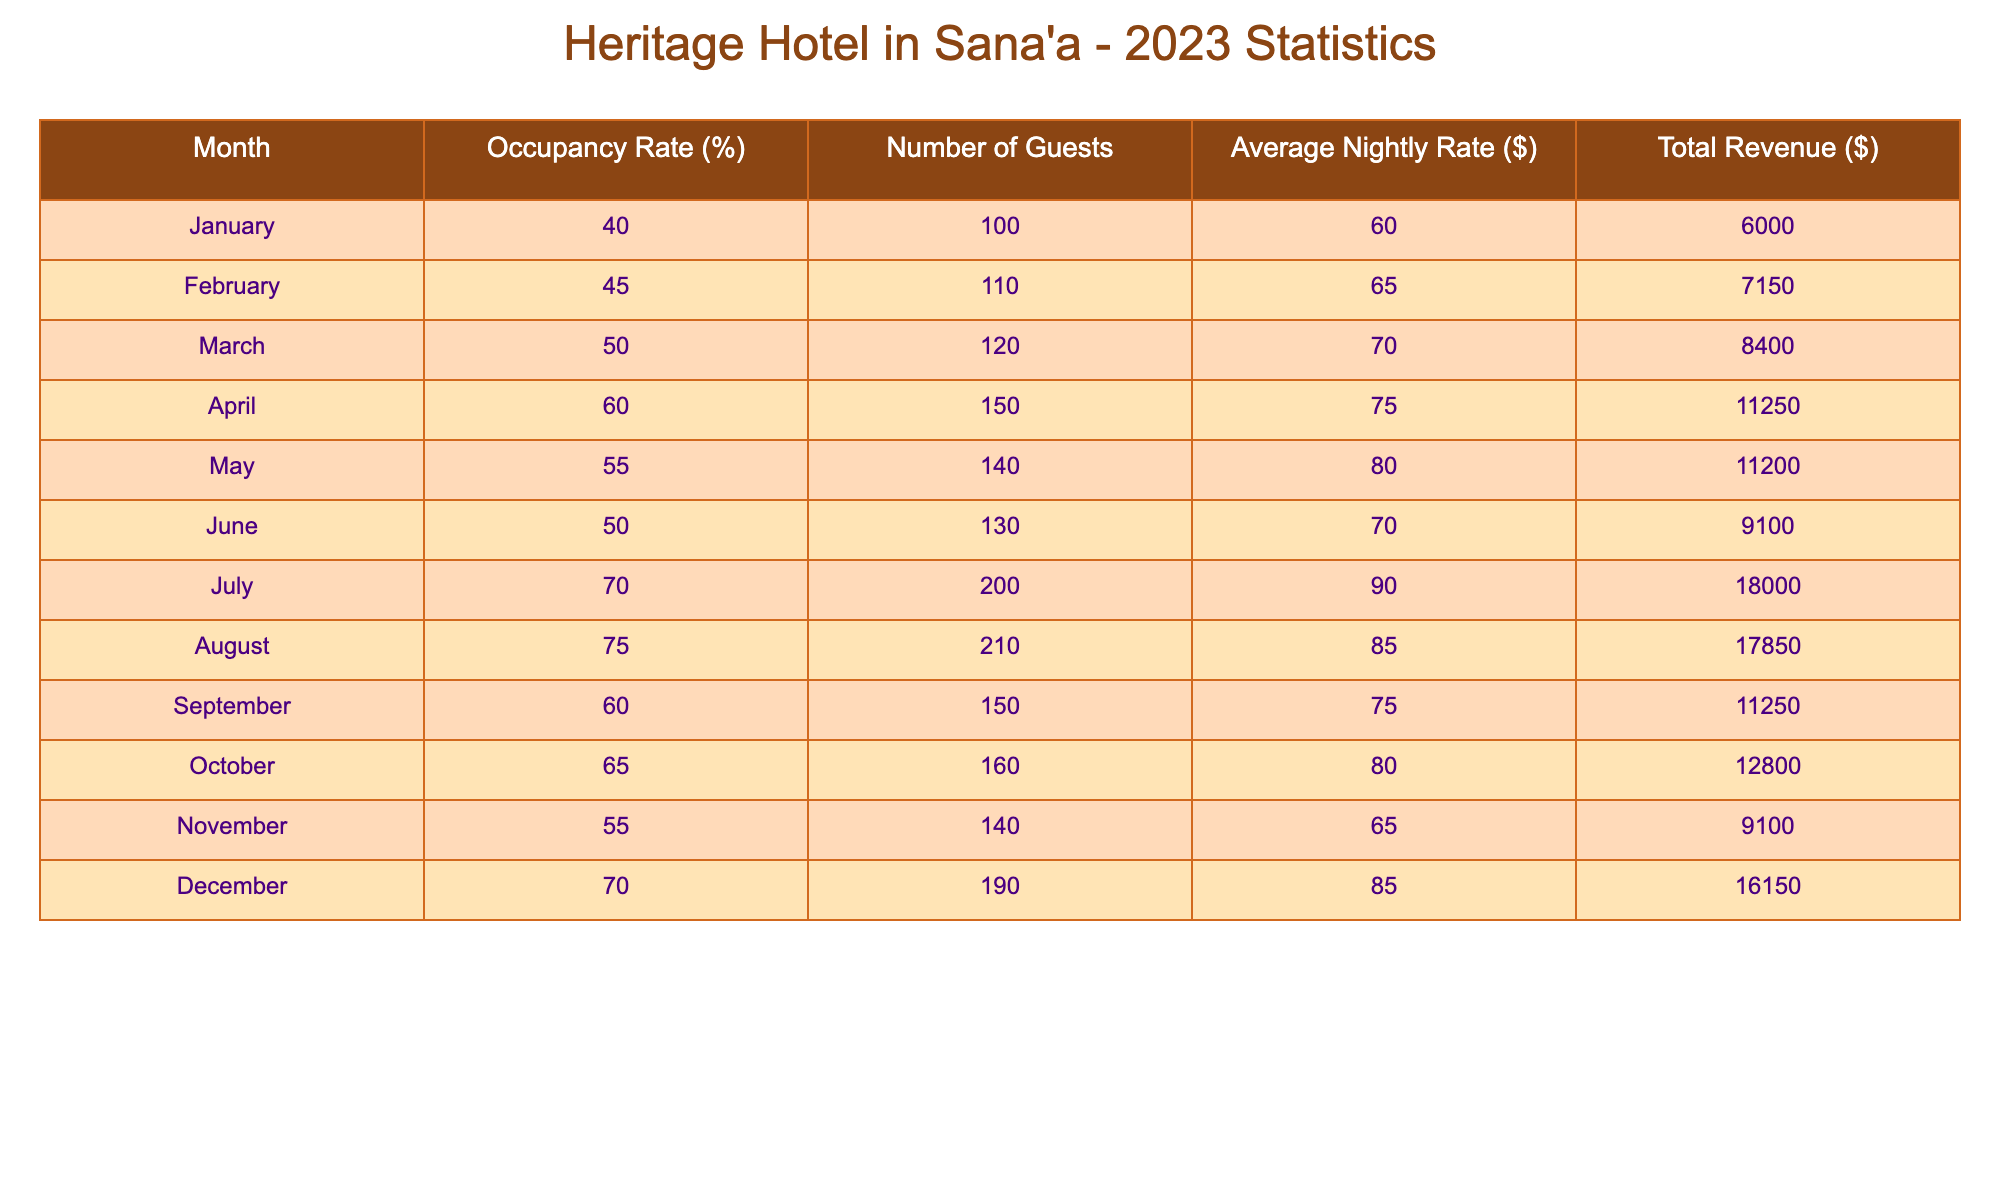What's the occupancy rate in July? The table shows the occupancy rate for each month. In July, the occupancy rate is listed as 70%.
Answer: 70% What is the average nightly rate for the month of April? I refer to the row for April in the table, which shows that the average nightly rate in April is $75.
Answer: 75 How many guests stayed in September? Looking at the September row in the table, I can see that 150 guests stayed during that month.
Answer: 150 What is the total revenue for the hotel in August? The table shows that the total revenue for August is $17,850, which is the value in the corresponding row.
Answer: 17850 What is the difference in occupancy rates between October and February? The occupancy rate in October is 65%, and in February it is 45%. To find the difference, I subtract February's rate from October's: 65% - 45% = 20%.
Answer: 20% Is the total revenue higher in December than in November? The total revenue for December is $16,150 and for November it is $9,100. Since 16,150 is greater than 9,100, the answer is yes.
Answer: Yes What is the average occupancy rate for the first half of the year (January to June)? The occupancy rates for the first half of the year are: January (40%), February (45%), March (50%), April (60%), May (55%), and June (50%). The sum is 40 + 45 + 50 + 60 + 55 + 50 = 300; there are 6 months, so the average is 300/6 = 50%.
Answer: 50% How many guests were there in total for the entire year? I will sum the number of guests for each month: 100 (January) + 110 (February) + 120 (March) + 150 (April) + 140 (May) + 130 (June) + 200 (July) + 210 (August) + 150 (September) + 160 (October) + 140 (November) + 190 (December) = 1,680.
Answer: 1680 Was the average nightly rate ever above $80 during the year? Reviewing the average nightly rates for each month, I see that the rates for July ($90) and August ($85) were both above $80. Therefore, the answer is yes.
Answer: Yes 